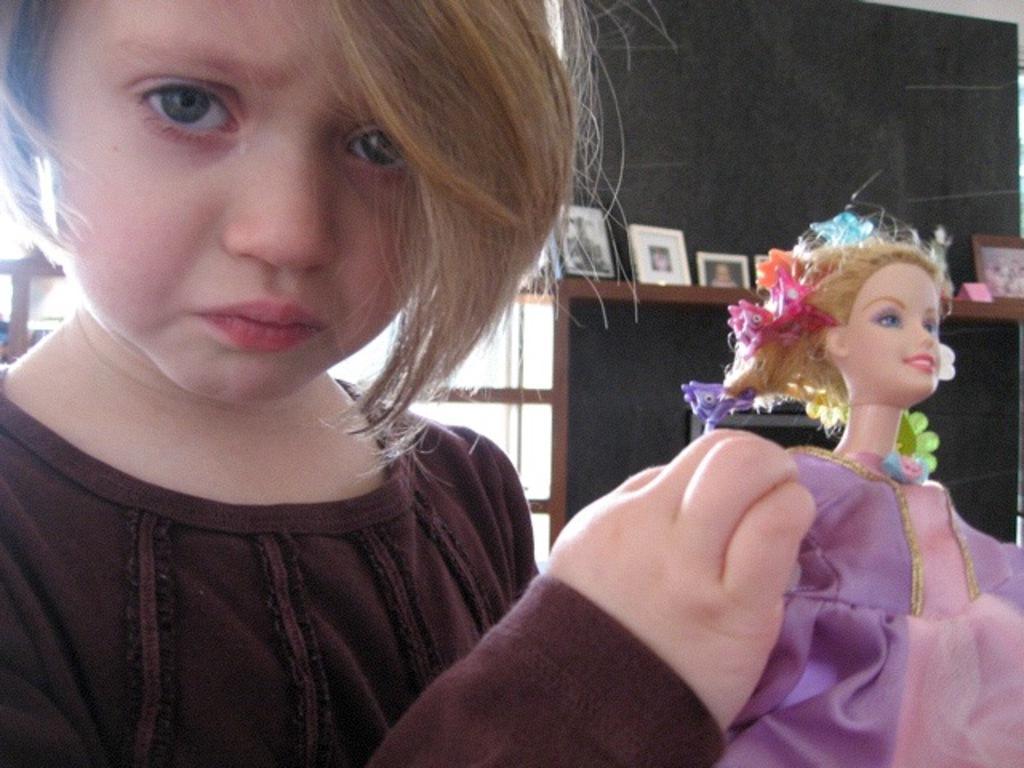Please provide a concise description of this image. In this image I can see a person holding a doll. The person is wearing brown shirt, at the back I can see few frames and the wall is in gray color. 